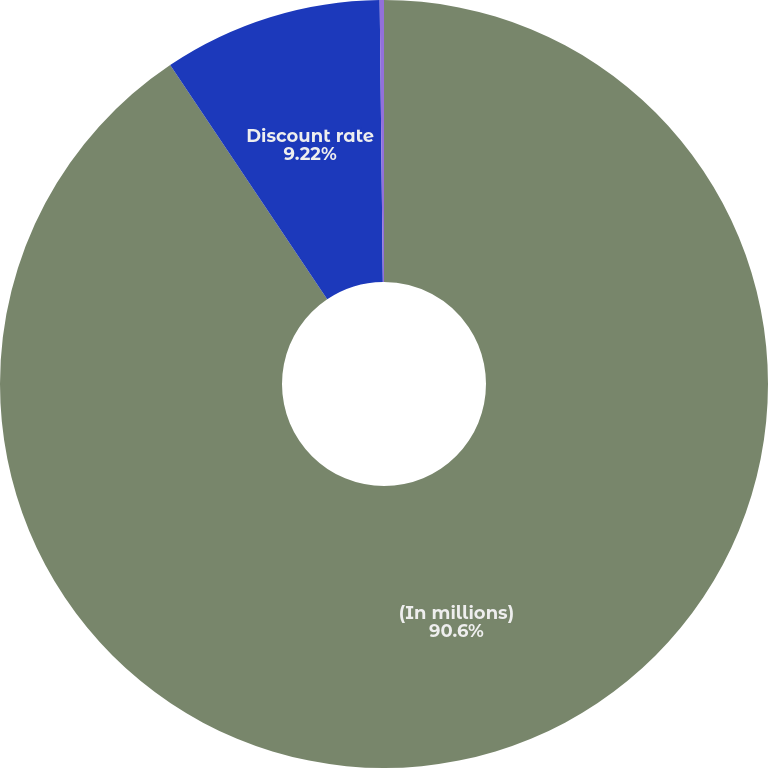Convert chart to OTSL. <chart><loc_0><loc_0><loc_500><loc_500><pie_chart><fcel>(In millions)<fcel>Discount rate<fcel>Average rate of increase in<nl><fcel>90.6%<fcel>9.22%<fcel>0.18%<nl></chart> 